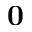Convert formula to latex. <formula><loc_0><loc_0><loc_500><loc_500>0</formula> 